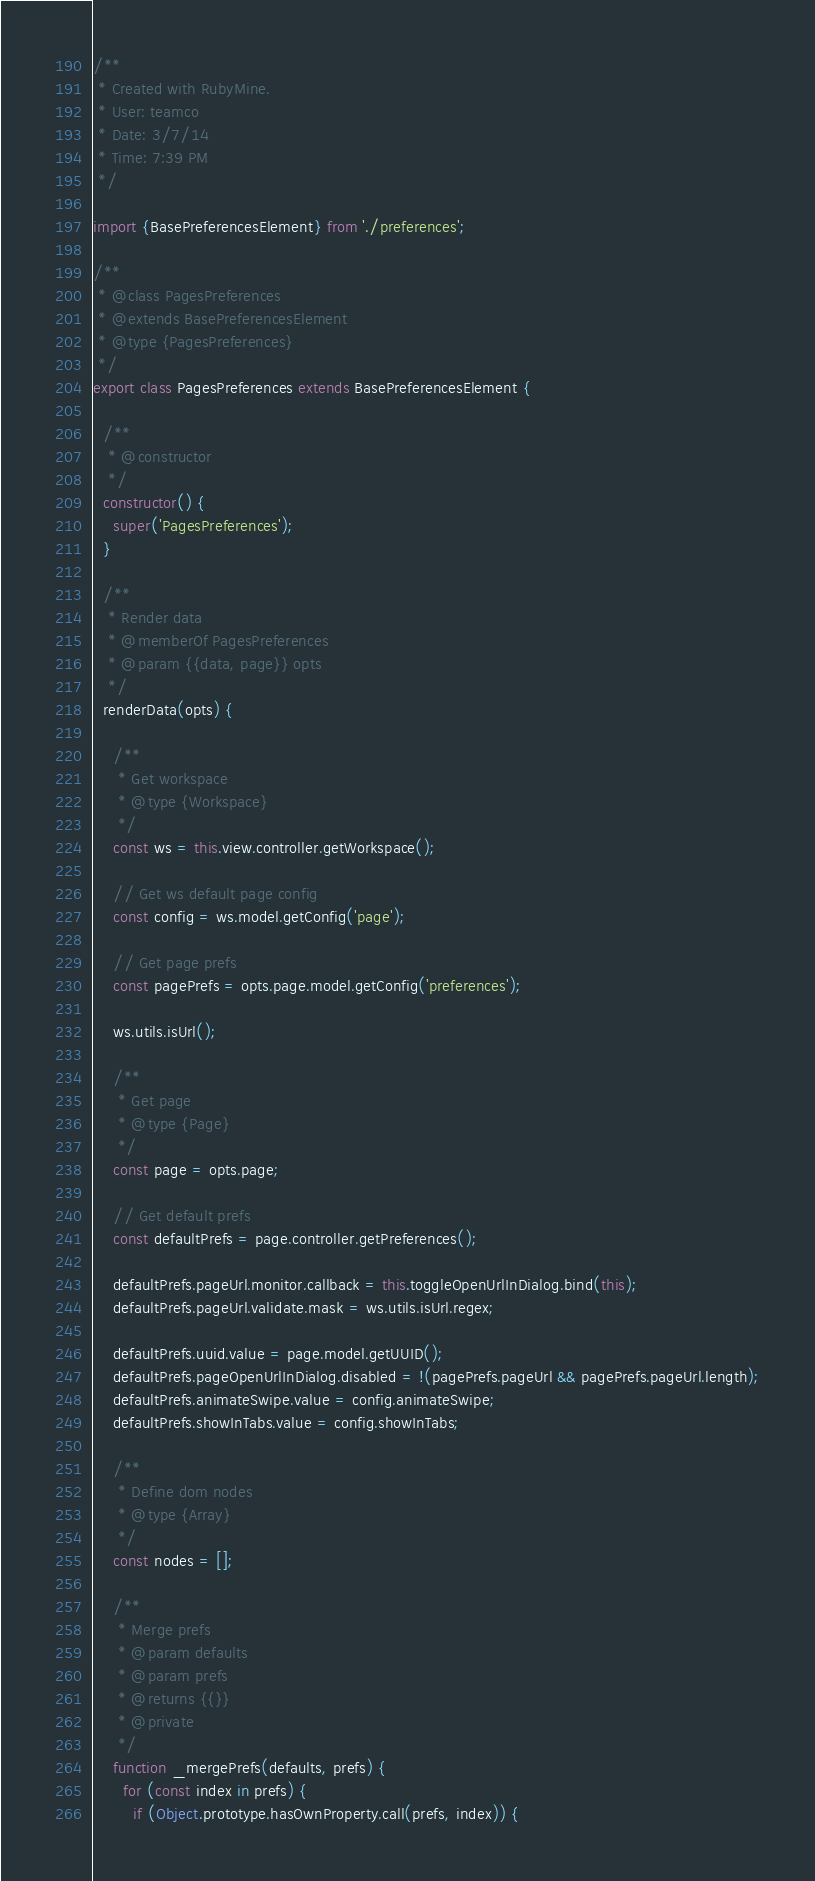<code> <loc_0><loc_0><loc_500><loc_500><_JavaScript_>/**
 * Created with RubyMine.
 * User: teamco
 * Date: 3/7/14
 * Time: 7:39 PM
 */

import {BasePreferencesElement} from './preferences';

/**
 * @class PagesPreferences
 * @extends BasePreferencesElement
 * @type {PagesPreferences}
 */
export class PagesPreferences extends BasePreferencesElement {

  /**
   * @constructor
   */
  constructor() {
    super('PagesPreferences');
  }

  /**
   * Render data
   * @memberOf PagesPreferences
   * @param {{data, page}} opts
   */
  renderData(opts) {

    /**
     * Get workspace
     * @type {Workspace}
     */
    const ws = this.view.controller.getWorkspace();

    // Get ws default page config
    const config = ws.model.getConfig('page');

    // Get page prefs
    const pagePrefs = opts.page.model.getConfig('preferences');

    ws.utils.isUrl();

    /**
     * Get page
     * @type {Page}
     */
    const page = opts.page;

    // Get default prefs
    const defaultPrefs = page.controller.getPreferences();

    defaultPrefs.pageUrl.monitor.callback = this.toggleOpenUrlInDialog.bind(this);
    defaultPrefs.pageUrl.validate.mask = ws.utils.isUrl.regex;

    defaultPrefs.uuid.value = page.model.getUUID();
    defaultPrefs.pageOpenUrlInDialog.disabled = !(pagePrefs.pageUrl && pagePrefs.pageUrl.length);
    defaultPrefs.animateSwipe.value = config.animateSwipe;
    defaultPrefs.showInTabs.value = config.showInTabs;

    /**
     * Define dom nodes
     * @type {Array}
     */
    const nodes = [];

    /**
     * Merge prefs
     * @param defaults
     * @param prefs
     * @returns {{}}
     * @private
     */
    function _mergePrefs(defaults, prefs) {
      for (const index in prefs) {
        if (Object.prototype.hasOwnProperty.call(prefs, index)) {</code> 